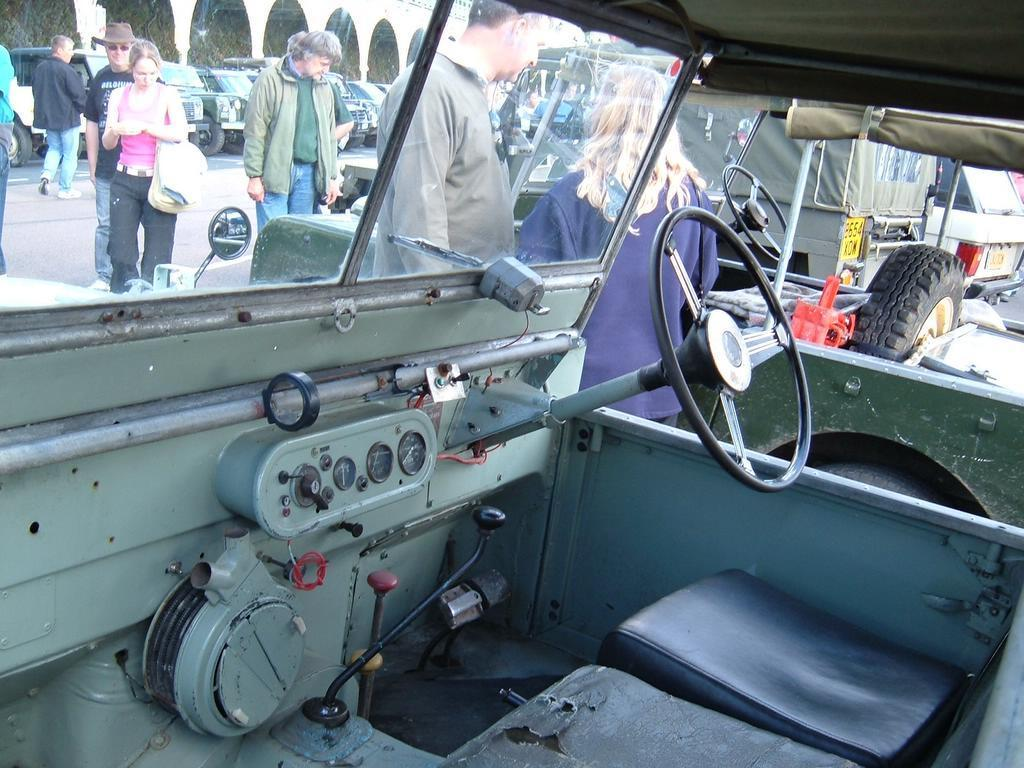What is the perspective of the image? The image is taken from inside a car. What can be seen happening on the road in the image? There are people walking on the road in the image. What else is visible on the road in the image? There are cars on either side of the road in the image. What type of coat is the person in the image wearing? There is no person visible in the image, as it is taken from inside a car. What historical event is being depicted in the image? The image does not depict any historical event; it shows a view of a road with people walking and cars parked on either side. 